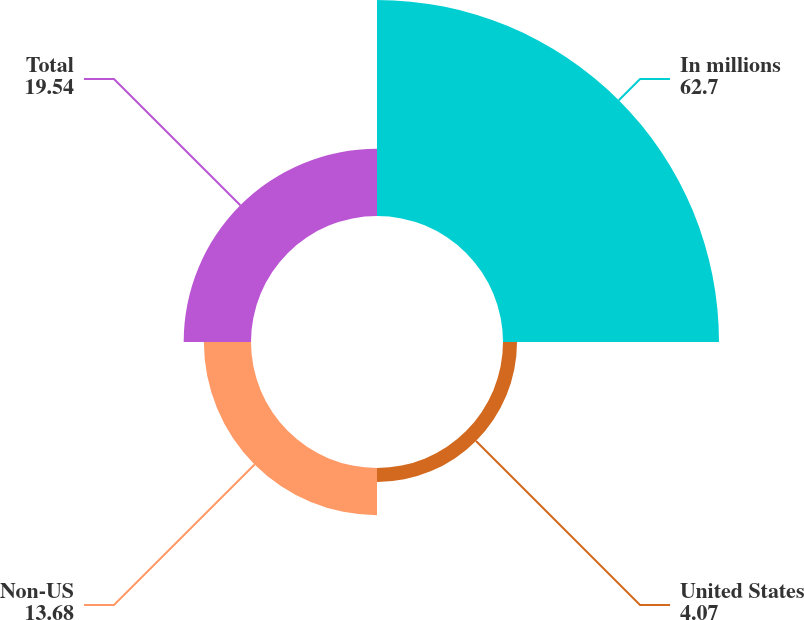Convert chart. <chart><loc_0><loc_0><loc_500><loc_500><pie_chart><fcel>In millions<fcel>United States<fcel>Non-US<fcel>Total<nl><fcel>62.7%<fcel>4.07%<fcel>13.68%<fcel>19.54%<nl></chart> 